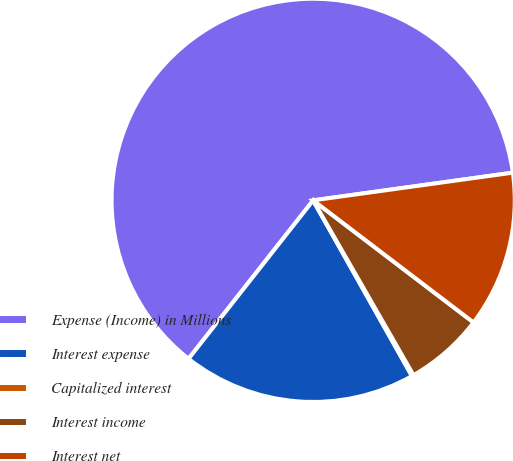Convert chart. <chart><loc_0><loc_0><loc_500><loc_500><pie_chart><fcel>Expense (Income) in Millions<fcel>Interest expense<fcel>Capitalized interest<fcel>Interest income<fcel>Interest net<nl><fcel>62.2%<fcel>18.76%<fcel>0.14%<fcel>6.35%<fcel>12.55%<nl></chart> 